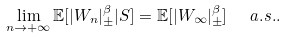Convert formula to latex. <formula><loc_0><loc_0><loc_500><loc_500>\lim _ { n \rightarrow + \infty } { \mathbb { E } } [ | W _ { n } | _ { \pm } ^ { \beta } | S ] = { \mathbb { E } } [ | W _ { \infty } | _ { \pm } ^ { \beta } ] \ \ a . s . .</formula> 